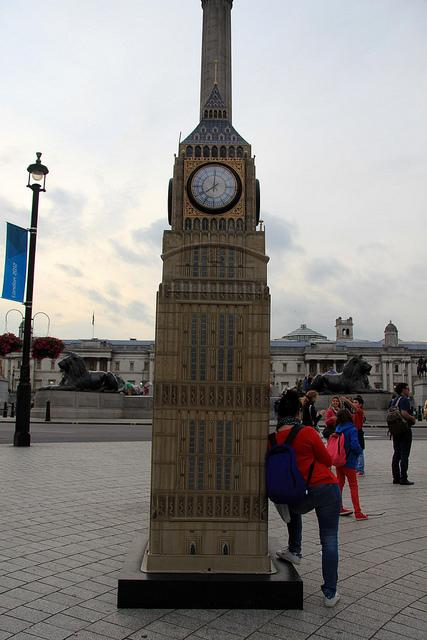What public service does the structure seen here serve? tell time 